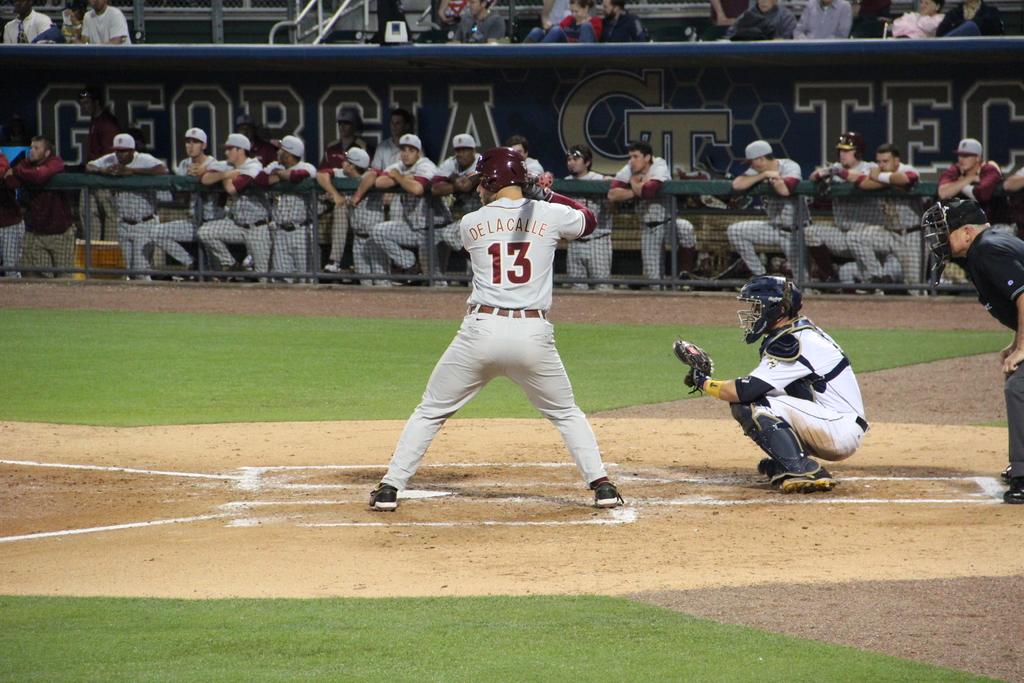What number is the batters number ?
Your answer should be compact. 13. What is the country name printed in the board?
Give a very brief answer. Georgia. 